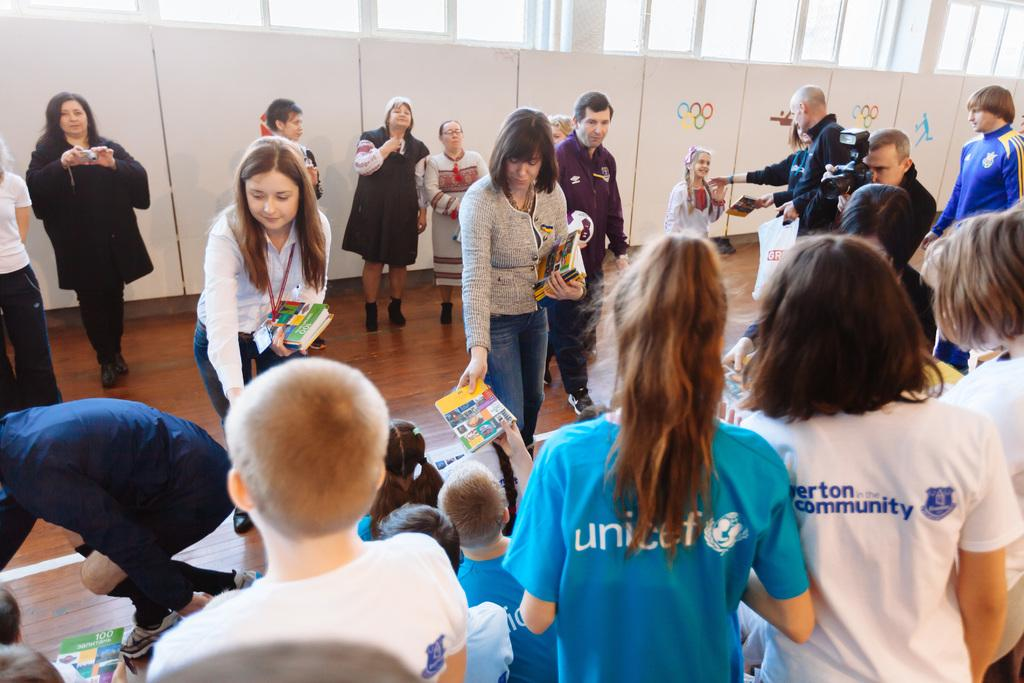What are the people in the image doing? Some people are standing, and others are sitting in the image. What can be seen in the background of the image? In the background of the image, there are posters. What is depicted on the posters? The posters have symbols on them. Can you tell me how many horses are depicted on the posters in the image? There are no horses depicted on the posters in the image; they have symbols on them. What type of chess piece is shown in the middle of the image? There is no chess piece present in the image; it features people standing and sitting, as well as posters with symbols. 